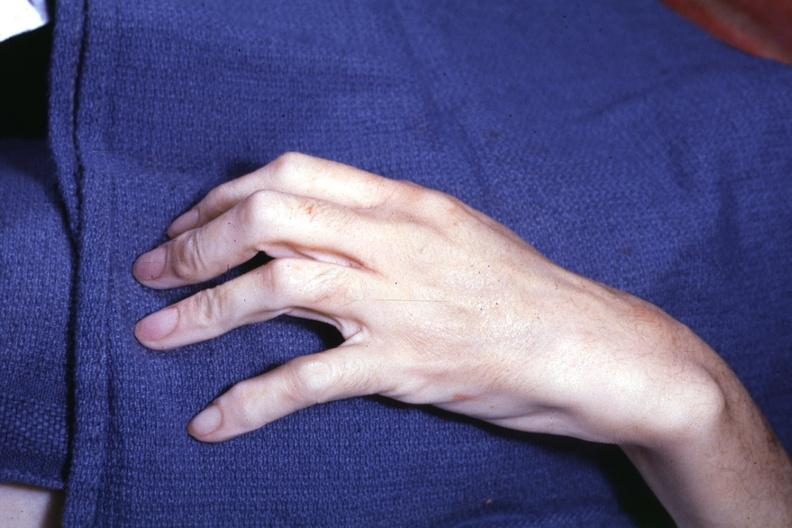does this image show long fingers interesting case see other slides?
Answer the question using a single word or phrase. Yes 